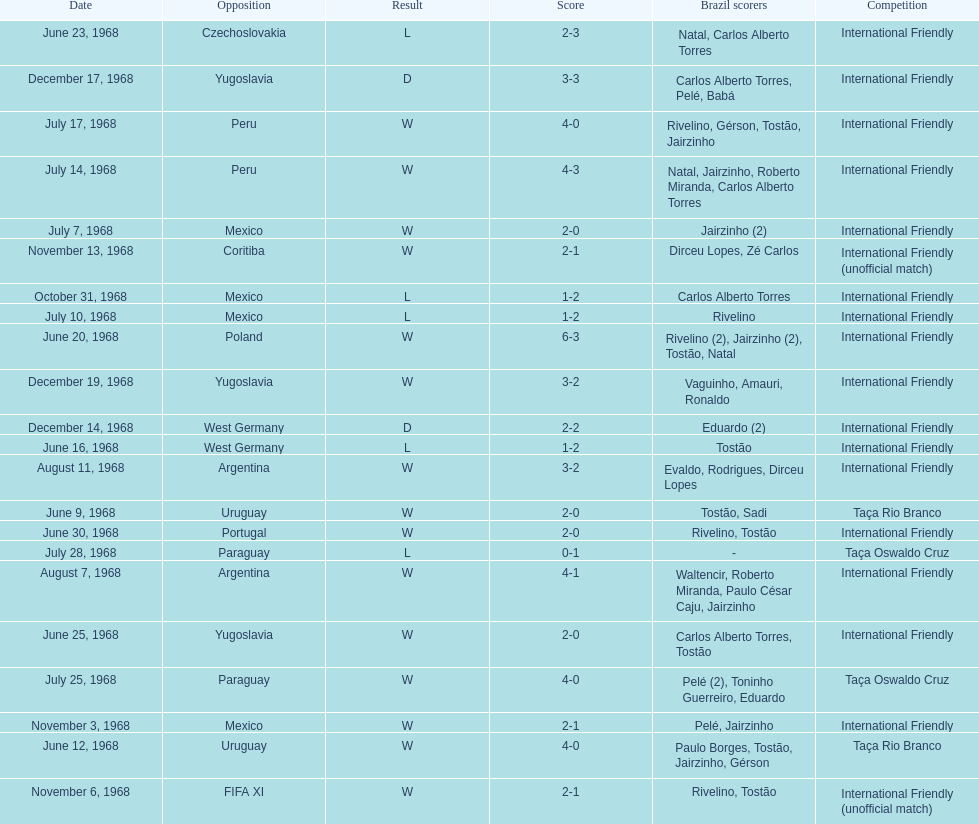Help me parse the entirety of this table. {'header': ['Date', 'Opposition', 'Result', 'Score', 'Brazil scorers', 'Competition'], 'rows': [['June 23, 1968', 'Czechoslovakia', 'L', '2-3', 'Natal, Carlos Alberto Torres', 'International Friendly'], ['December 17, 1968', 'Yugoslavia', 'D', '3-3', 'Carlos Alberto Torres, Pelé, Babá', 'International Friendly'], ['July 17, 1968', 'Peru', 'W', '4-0', 'Rivelino, Gérson, Tostão, Jairzinho', 'International Friendly'], ['July 14, 1968', 'Peru', 'W', '4-3', 'Natal, Jairzinho, Roberto Miranda, Carlos Alberto Torres', 'International Friendly'], ['July 7, 1968', 'Mexico', 'W', '2-0', 'Jairzinho (2)', 'International Friendly'], ['November 13, 1968', 'Coritiba', 'W', '2-1', 'Dirceu Lopes, Zé Carlos', 'International Friendly (unofficial match)'], ['October 31, 1968', 'Mexico', 'L', '1-2', 'Carlos Alberto Torres', 'International Friendly'], ['July 10, 1968', 'Mexico', 'L', '1-2', 'Rivelino', 'International Friendly'], ['June 20, 1968', 'Poland', 'W', '6-3', 'Rivelino (2), Jairzinho (2), Tostão, Natal', 'International Friendly'], ['December 19, 1968', 'Yugoslavia', 'W', '3-2', 'Vaguinho, Amauri, Ronaldo', 'International Friendly'], ['December 14, 1968', 'West Germany', 'D', '2-2', 'Eduardo (2)', 'International Friendly'], ['June 16, 1968', 'West Germany', 'L', '1-2', 'Tostão', 'International Friendly'], ['August 11, 1968', 'Argentina', 'W', '3-2', 'Evaldo, Rodrigues, Dirceu Lopes', 'International Friendly'], ['June 9, 1968', 'Uruguay', 'W', '2-0', 'Tostão, Sadi', 'Taça Rio Branco'], ['June 30, 1968', 'Portugal', 'W', '2-0', 'Rivelino, Tostão', 'International Friendly'], ['July 28, 1968', 'Paraguay', 'L', '0-1', '-', 'Taça Oswaldo Cruz'], ['August 7, 1968', 'Argentina', 'W', '4-1', 'Waltencir, Roberto Miranda, Paulo César Caju, Jairzinho', 'International Friendly'], ['June 25, 1968', 'Yugoslavia', 'W', '2-0', 'Carlos Alberto Torres, Tostão', 'International Friendly'], ['July 25, 1968', 'Paraguay', 'W', '4-0', 'Pelé (2), Toninho Guerreiro, Eduardo', 'Taça Oswaldo Cruz'], ['November 3, 1968', 'Mexico', 'W', '2-1', 'Pelé, Jairzinho', 'International Friendly'], ['June 12, 1968', 'Uruguay', 'W', '4-0', 'Paulo Borges, Tostão, Jairzinho, Gérson', 'Taça Rio Branco'], ['November 6, 1968', 'FIFA XI', 'W', '2-1', 'Rivelino, Tostão', 'International Friendly (unofficial match)']]} The most goals scored by brazil in a game 6. 